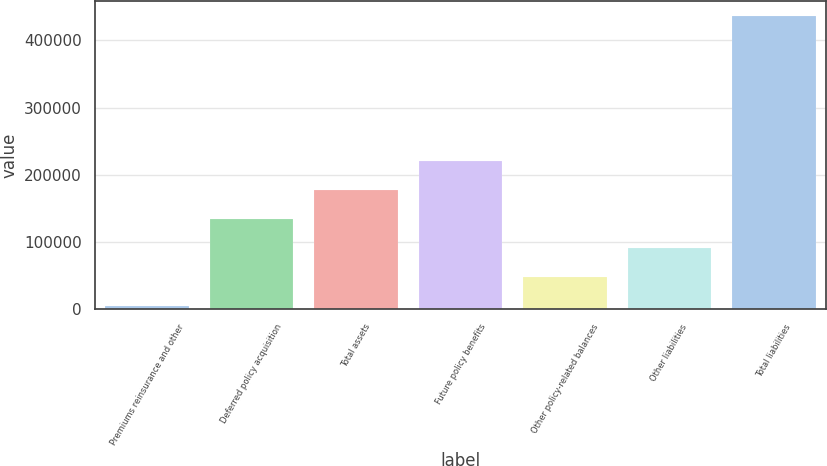Convert chart to OTSL. <chart><loc_0><loc_0><loc_500><loc_500><bar_chart><fcel>Premiums reinsurance and other<fcel>Deferred policy acquisition<fcel>Total assets<fcel>Future policy benefits<fcel>Other policy-related balances<fcel>Other liabilities<fcel>Total liabilities<nl><fcel>5601<fcel>134904<fcel>178005<fcel>221106<fcel>48702.1<fcel>91803.2<fcel>436612<nl></chart> 